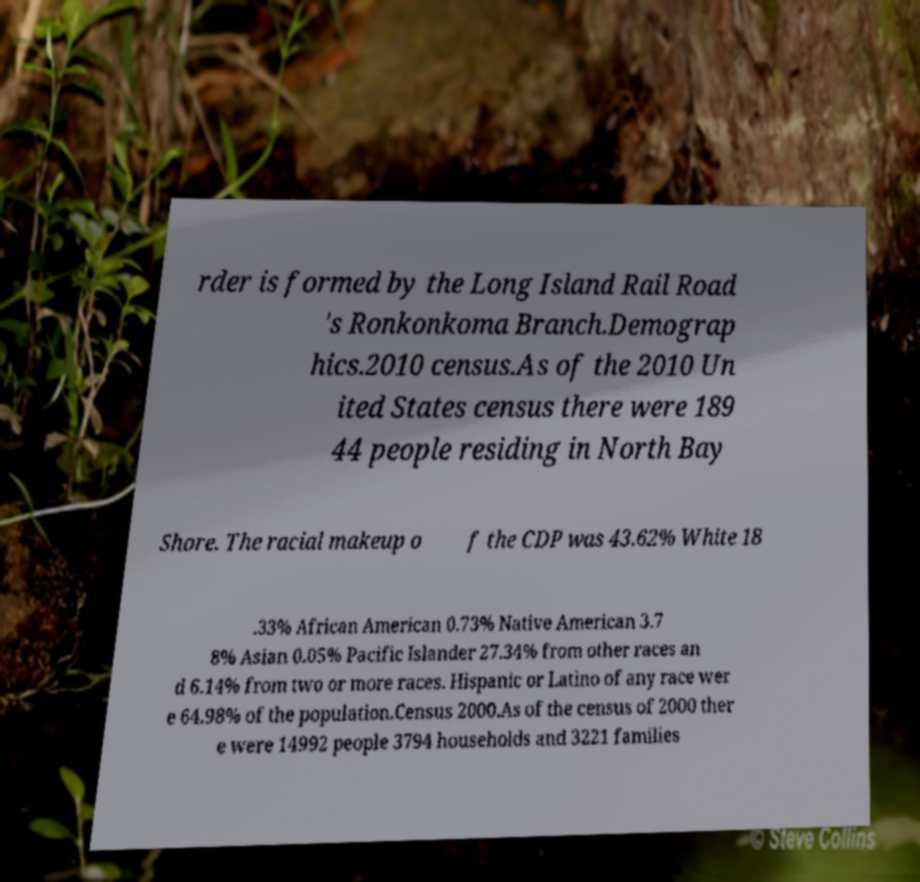Can you accurately transcribe the text from the provided image for me? rder is formed by the Long Island Rail Road 's Ronkonkoma Branch.Demograp hics.2010 census.As of the 2010 Un ited States census there were 189 44 people residing in North Bay Shore. The racial makeup o f the CDP was 43.62% White 18 .33% African American 0.73% Native American 3.7 8% Asian 0.05% Pacific Islander 27.34% from other races an d 6.14% from two or more races. Hispanic or Latino of any race wer e 64.98% of the population.Census 2000.As of the census of 2000 ther e were 14992 people 3794 households and 3221 families 